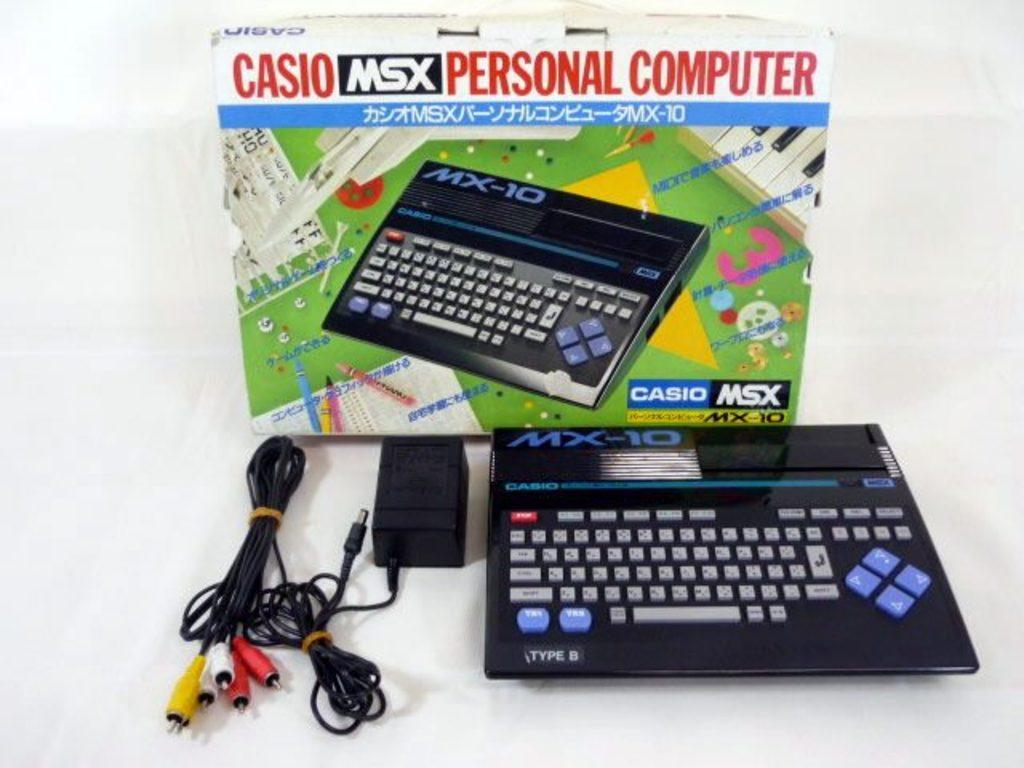<image>
Present a compact description of the photo's key features. Casio msx personal computer with the charger that  goes to it 